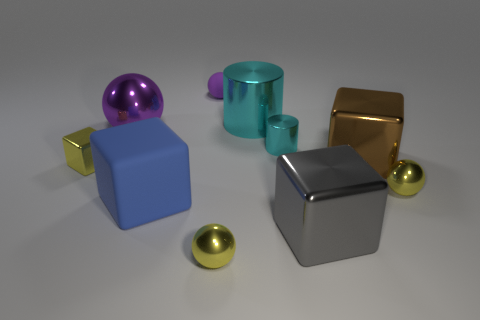Are there fewer yellow metallic objects behind the large blue block than cyan metallic cylinders?
Your answer should be very brief. No. There is a metallic block right of the large shiny object that is in front of the yellow metal ball that is behind the big gray shiny thing; what is its color?
Your answer should be compact. Brown. Is there any other thing that is made of the same material as the large ball?
Your response must be concise. Yes. The yellow metallic object that is the same shape as the big brown object is what size?
Your answer should be compact. Small. Is the number of large brown shiny blocks that are behind the large brown shiny thing less than the number of big blue rubber things in front of the large gray cube?
Keep it short and to the point. No. There is a tiny object that is right of the big metallic cylinder and in front of the small cylinder; what is its shape?
Provide a succinct answer. Sphere. What is the size of the gray thing that is the same material as the large brown cube?
Make the answer very short. Large. There is a tiny metal cube; is its color the same as the ball to the left of the purple matte sphere?
Provide a short and direct response. No. There is a yellow thing that is behind the big blue rubber object and on the left side of the brown cube; what material is it made of?
Give a very brief answer. Metal. The thing that is the same color as the tiny metal cylinder is what size?
Your answer should be very brief. Large. 